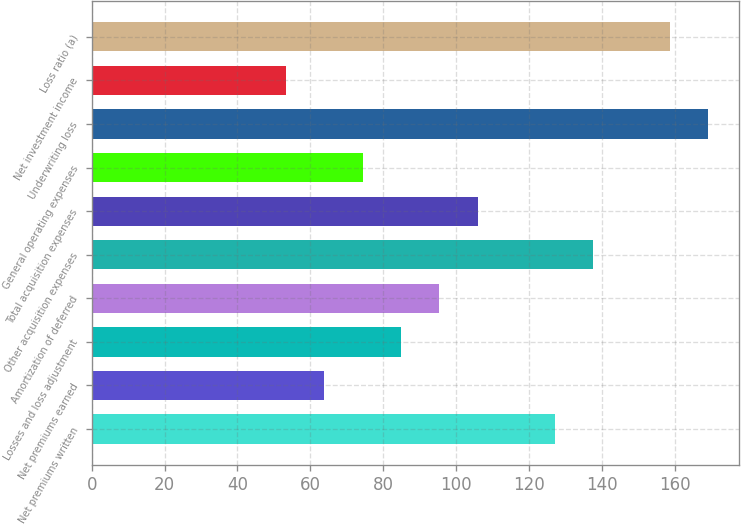Convert chart. <chart><loc_0><loc_0><loc_500><loc_500><bar_chart><fcel>Net premiums written<fcel>Net premiums earned<fcel>Losses and loss adjustment<fcel>Amortization of deferred<fcel>Other acquisition expenses<fcel>Total acquisition expenses<fcel>General operating expenses<fcel>Underwriting loss<fcel>Net investment income<fcel>Loss ratio (a)<nl><fcel>127.06<fcel>63.88<fcel>84.94<fcel>95.47<fcel>137.59<fcel>106<fcel>74.41<fcel>169.18<fcel>53.35<fcel>158.65<nl></chart> 